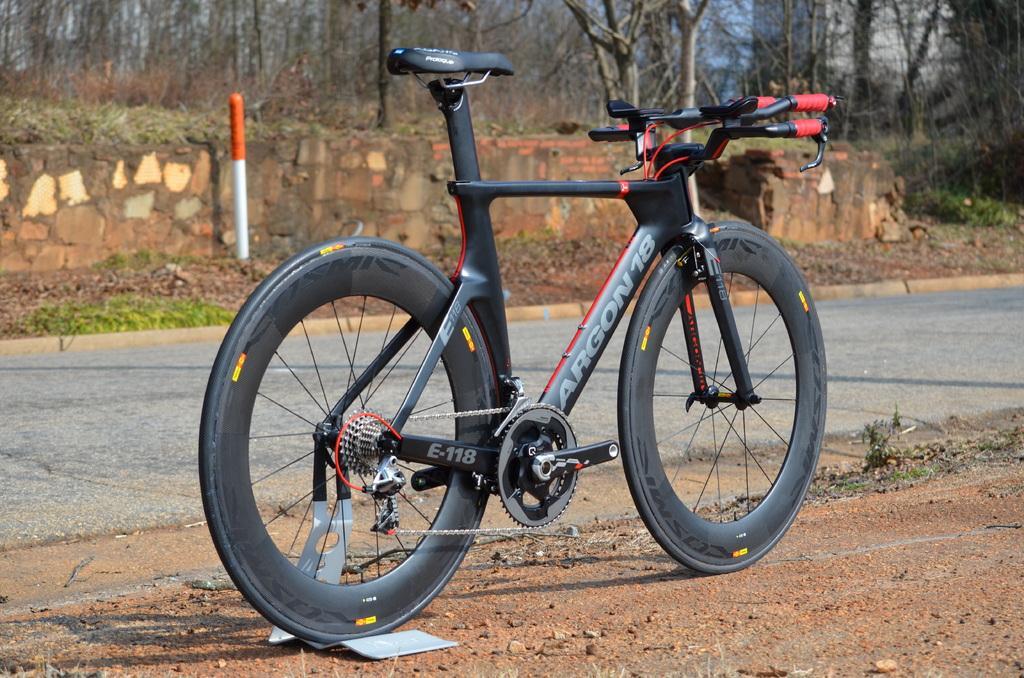Describe this image in one or two sentences. In this image, we can see a bicycle with stand is parked on the ground. Background there is a road, pole, plants, trees, wall we can see. 